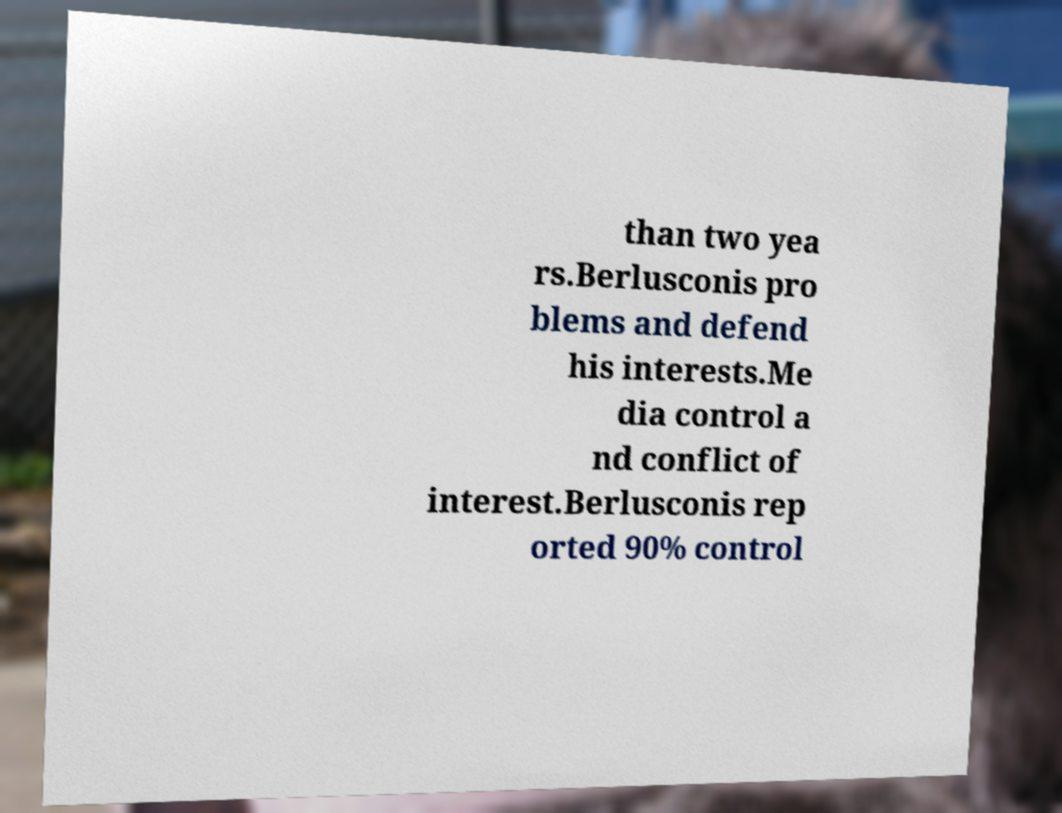Please identify and transcribe the text found in this image. than two yea rs.Berlusconis pro blems and defend his interests.Me dia control a nd conflict of interest.Berlusconis rep orted 90% control 